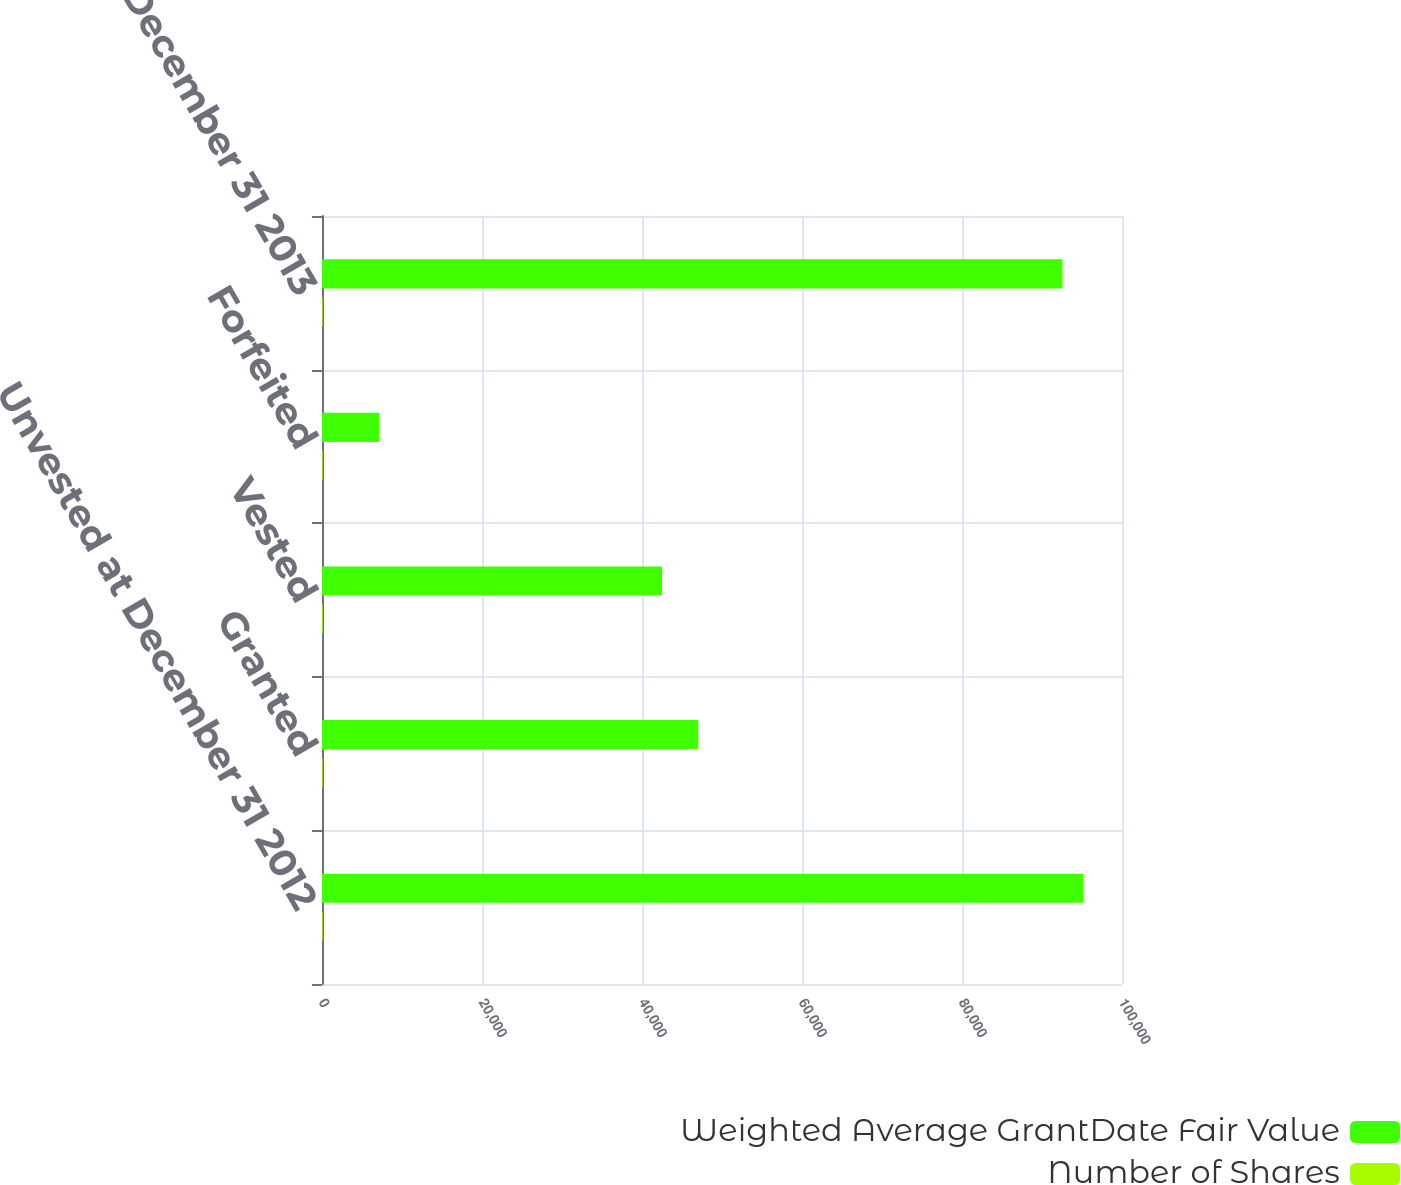Convert chart. <chart><loc_0><loc_0><loc_500><loc_500><stacked_bar_chart><ecel><fcel>Unvested at December 31 2012<fcel>Granted<fcel>Vested<fcel>Forfeited<fcel>Unvested at December 31 2013<nl><fcel>Weighted Average GrantDate Fair Value<fcel>95167<fcel>47032<fcel>42498<fcel>7156<fcel>92545<nl><fcel>Number of Shares<fcel>81.12<fcel>80.47<fcel>91.41<fcel>81.19<fcel>76.05<nl></chart> 